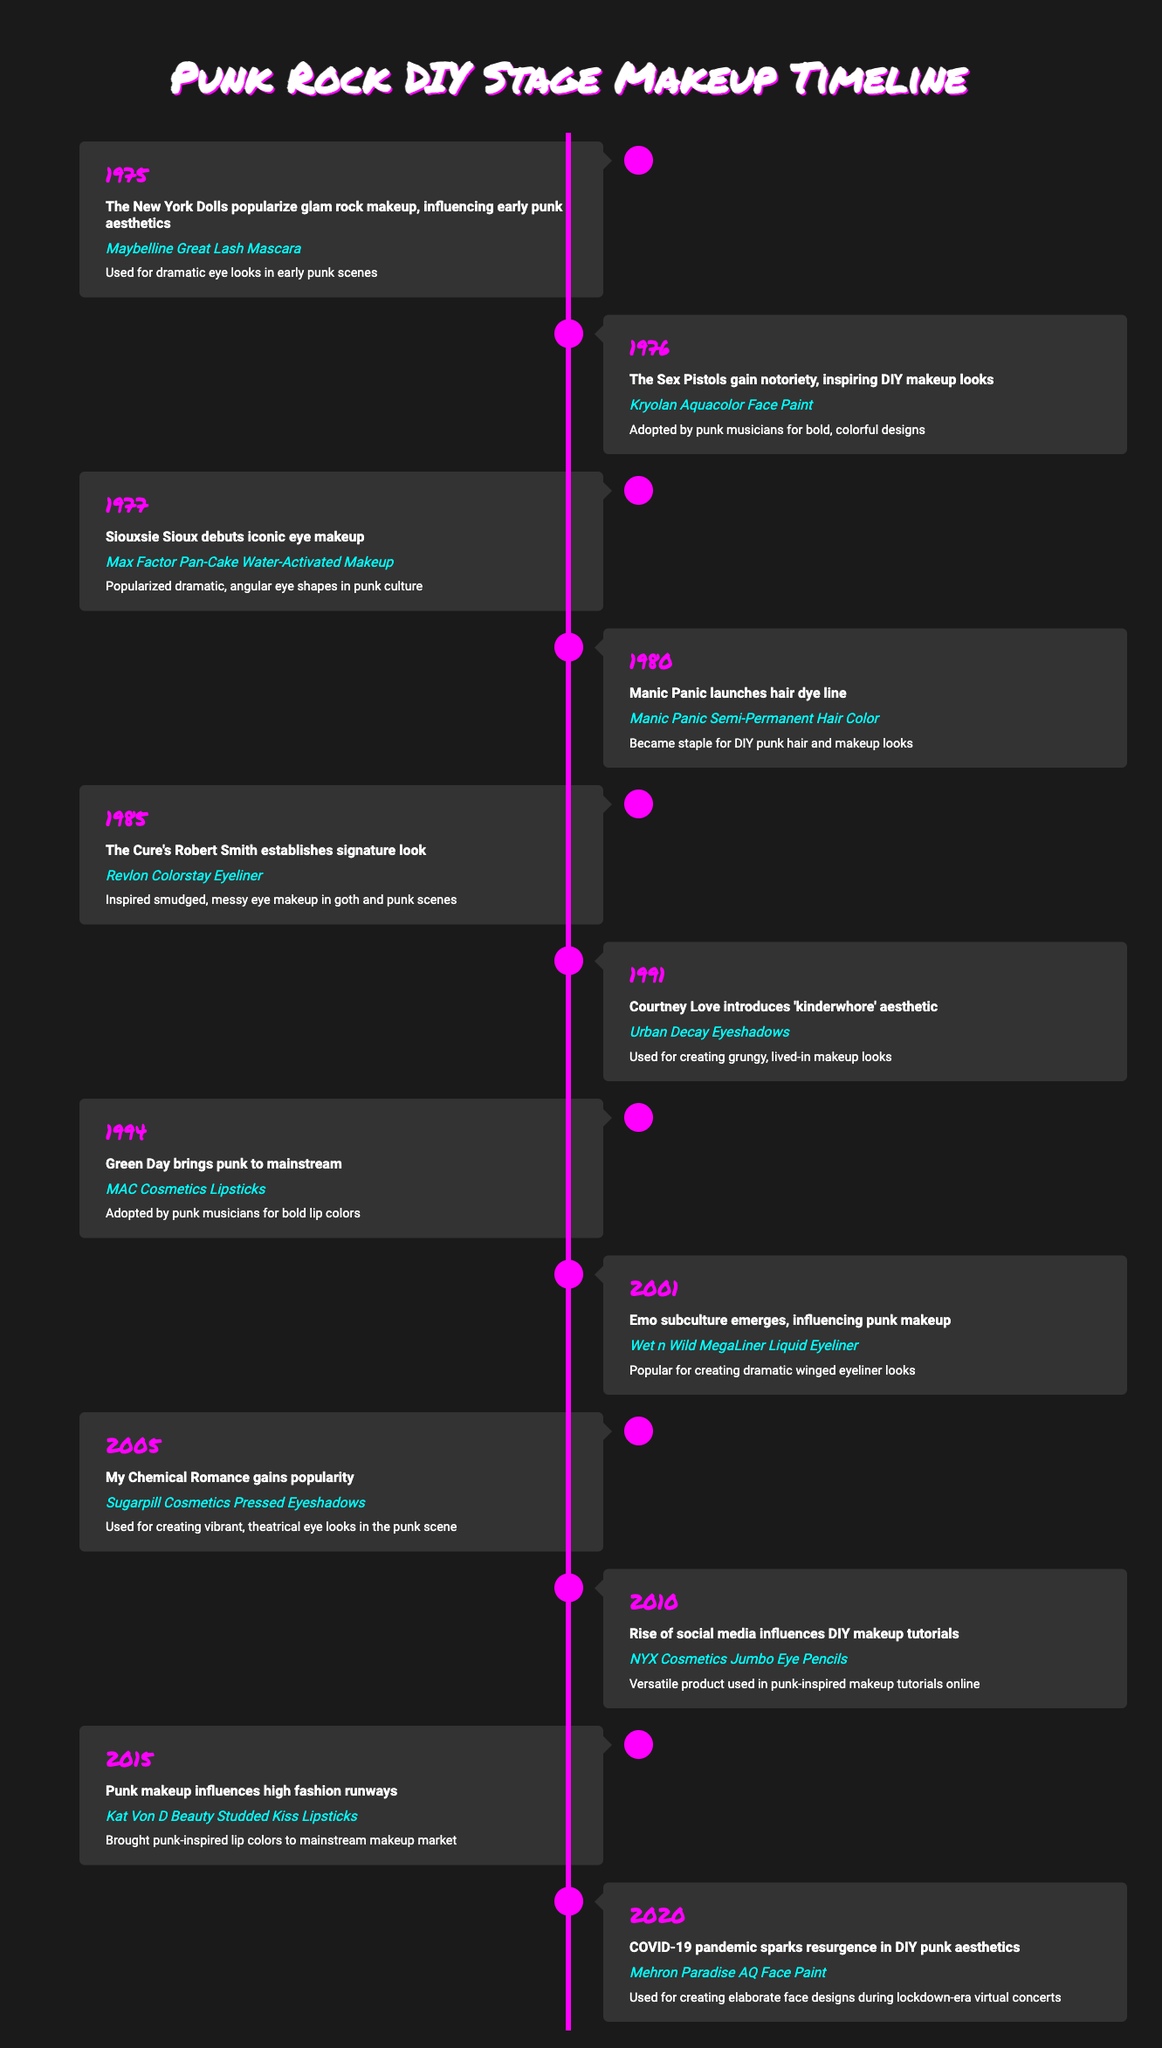What year did The New York Dolls influence early punk aesthetics? The table states that The New York Dolls popularized glam rock makeup in 1975, which influenced early punk aesthetics.
Answer: 1975 Which product was adopted by punk musicians for bold, colorful designs in 1976? According to the timeline, in 1976, Kryolan Aquacolor Face Paint was adopted by punk musicians for bold, colorful designs.
Answer: Kryolan Aquacolor Face Paint How many years passed between the debut of Siouxsie Sioux's iconic eye makeup and the launch of Manic Panic's hair dye line? Siouxsie Sioux's iconic eye makeup debuted in 1977 and Manic Panic launched their hair dye line in 1980. The difference is 1980 - 1977 = 3 years.
Answer: 3 years Did Urban Decay Eyeshadows introduce the 'kinderwhore' aesthetic? The table indicates that Courtney Love introduced the 'kinderwhore' aesthetic in 1991 using Urban Decay Eyeshadows. Thus, the statement is true.
Answer: Yes Which product was particularly influential during the COVID-19 pandemic in 2020? In 2020, Mehron Paradise AQ Face Paint was used for creating elaborate face designs during lockdown-era virtual concerts, according to the table.
Answer: Mehron Paradise AQ Face Paint What was the significance of using Revlon Colorstay Eyeliner in 1985? The timeline states that Revlon Colorstay Eyeliner inspired smudged, messy eye makeup in goth and punk scenes, highlighting its importance in that era.
Answer: Inspired smudged, messy eye makeup List all products introduced between 2010 and 2020. From the table, the products introduced between 2010 and 2020 are: NYX Cosmetics Jumbo Eye Pencils (2010), Kat Von D Beauty Studded Kiss Lipsticks (2015), and Mehron Paradise AQ Face Paint (2020). This involves retrieving the years and products from the specified range.
Answer: NYX Cosmetics Jumbo Eye Pencils, Kat Von D Beauty Studded Kiss Lipsticks, Mehron Paradise AQ Face Paint In which year did punk makeup influence high fashion runways? The table illustrates that in 2015, punk makeup began influencing high fashion runways, as indicated by the event listed in that year.
Answer: 2015 How many events occurred that were associated with creating dramatic eye looks in the timeline? The timeline displays events associated with dramatic eye looks in 1975 (Maybelline Great Lash Mascara), 1977 (Max Factor Pan-Cake Makeup), and 2001 (Wet n Wild MegaLiner Liquid Eyeliner) for a total of 3.
Answer: 3 events 